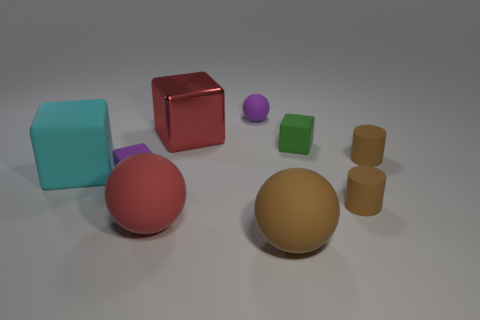Is there any other thing that has the same material as the red cube?
Ensure brevity in your answer.  No. The big matte object that is behind the big matte sphere that is on the left side of the shiny object is what shape?
Offer a terse response. Cube. Are there any red metal cubes that have the same size as the brown rubber ball?
Provide a succinct answer. Yes. Are there fewer small yellow blocks than red shiny objects?
Your answer should be compact. Yes. What is the shape of the brown rubber thing that is behind the big cyan block on the left side of the purple object behind the large red shiny thing?
Your response must be concise. Cylinder. What number of objects are either small purple matte balls that are behind the large cyan rubber object or rubber things that are in front of the metal thing?
Your answer should be very brief. 8. There is a brown ball; are there any large cyan matte things in front of it?
Give a very brief answer. No. What number of objects are small objects that are in front of the big metal block or purple rubber balls?
Your answer should be very brief. 5. How many green things are shiny objects or big balls?
Offer a terse response. 0. What number of other things are the same color as the metal object?
Keep it short and to the point. 1. 